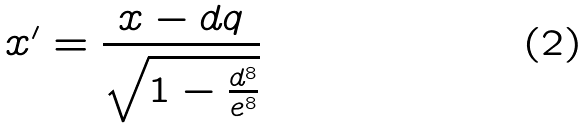<formula> <loc_0><loc_0><loc_500><loc_500>x ^ { \prime } = \frac { x - d q } { \sqrt { 1 - \frac { d ^ { 8 } } { e ^ { 8 } } } }</formula> 